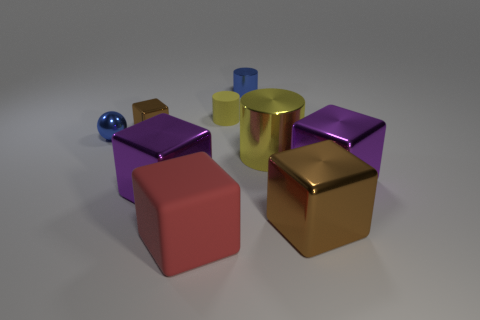Does the rubber cylinder that is right of the large matte block have the same size as the brown thing behind the blue shiny ball?
Offer a terse response. Yes. What number of objects are either big brown metallic things or purple metal things?
Your response must be concise. 3. What size is the metal cube behind the tiny ball?
Your response must be concise. Small. There is a purple object that is on the left side of the brown object that is right of the large yellow shiny cylinder; how many blue cylinders are left of it?
Offer a terse response. 0. Is the small matte object the same color as the large cylinder?
Offer a very short reply. Yes. How many cubes are left of the yellow shiny cylinder and behind the matte block?
Provide a short and direct response. 2. The metal object that is behind the small matte thing has what shape?
Ensure brevity in your answer.  Cylinder. Are there fewer yellow cylinders in front of the matte block than brown shiny cubes to the right of the tiny brown cube?
Offer a terse response. Yes. Does the large purple thing to the right of the big red block have the same material as the yellow object that is in front of the rubber cylinder?
Keep it short and to the point. Yes. The big matte object has what shape?
Provide a short and direct response. Cube. 